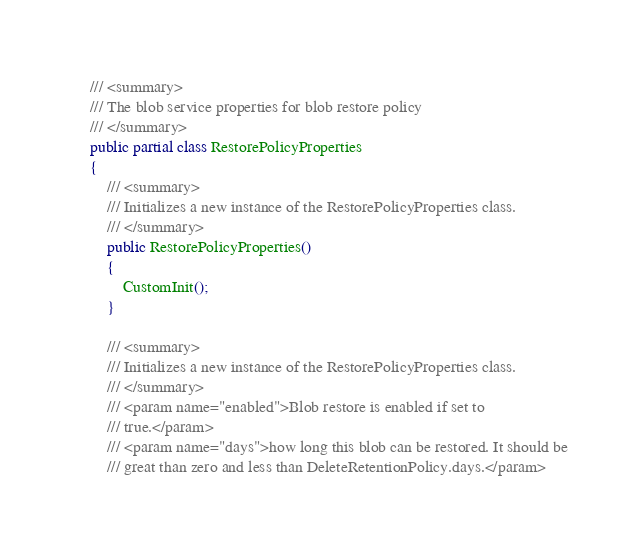Convert code to text. <code><loc_0><loc_0><loc_500><loc_500><_C#_>
    /// <summary>
    /// The blob service properties for blob restore policy
    /// </summary>
    public partial class RestorePolicyProperties
    {
        /// <summary>
        /// Initializes a new instance of the RestorePolicyProperties class.
        /// </summary>
        public RestorePolicyProperties()
        {
            CustomInit();
        }

        /// <summary>
        /// Initializes a new instance of the RestorePolicyProperties class.
        /// </summary>
        /// <param name="enabled">Blob restore is enabled if set to
        /// true.</param>
        /// <param name="days">how long this blob can be restored. It should be
        /// great than zero and less than DeleteRetentionPolicy.days.</param></code> 